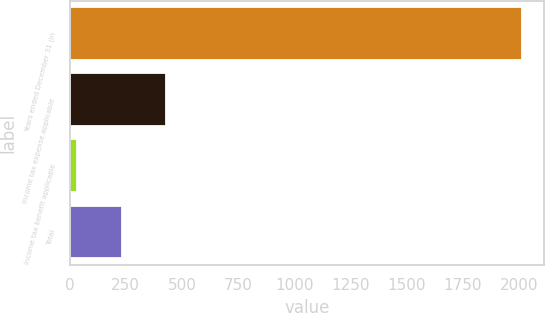Convert chart to OTSL. <chart><loc_0><loc_0><loc_500><loc_500><bar_chart><fcel>Years ended December 31 (in<fcel>Income tax expense applicable<fcel>Income tax benefit applicable<fcel>Total<nl><fcel>2013<fcel>430.28<fcel>34.6<fcel>232.44<nl></chart> 